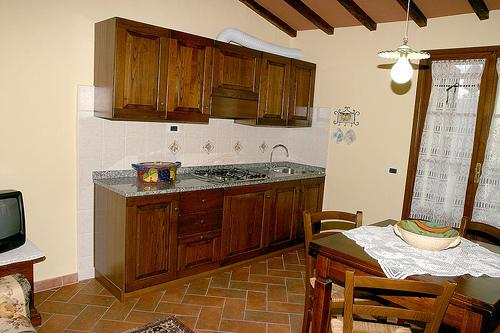Question: what room is this?
Choices:
A. The bathroom.
B. The kitchen.
C. The bedroom.
D. The basement.
Answer with the letter. Answer: B Question: what is on the table?
Choices:
A. A glass.
B. A plate.
C. A fork.
D. A bowl.
Answer with the letter. Answer: D Question: where is the oven?
Choices:
A. To the right of the sink.
B. To the left of the fridge.
C. To the left of the sink.
D. To the right of the fridge.
Answer with the letter. Answer: C 